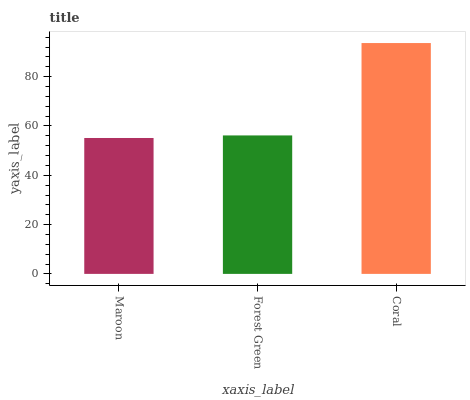Is Forest Green the minimum?
Answer yes or no. No. Is Forest Green the maximum?
Answer yes or no. No. Is Forest Green greater than Maroon?
Answer yes or no. Yes. Is Maroon less than Forest Green?
Answer yes or no. Yes. Is Maroon greater than Forest Green?
Answer yes or no. No. Is Forest Green less than Maroon?
Answer yes or no. No. Is Forest Green the high median?
Answer yes or no. Yes. Is Forest Green the low median?
Answer yes or no. Yes. Is Maroon the high median?
Answer yes or no. No. Is Maroon the low median?
Answer yes or no. No. 